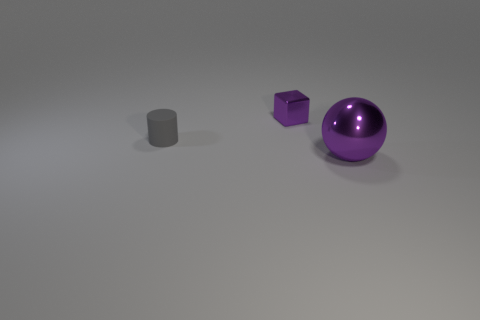Do the small matte thing and the large purple thing have the same shape?
Your answer should be very brief. No. The matte cylinder has what color?
Offer a very short reply. Gray. What number of things are big purple metallic spheres or purple rubber cubes?
Your answer should be very brief. 1. Is there anything else that has the same material as the gray cylinder?
Keep it short and to the point. No. Is the number of small gray objects that are right of the big purple object less than the number of tiny objects?
Give a very brief answer. Yes. Are there more big purple balls that are to the left of the tiny gray matte thing than shiny spheres behind the purple metal ball?
Ensure brevity in your answer.  No. Is there any other thing that is the same color as the big metallic ball?
Keep it short and to the point. Yes. What is the purple thing that is in front of the gray rubber cylinder made of?
Offer a terse response. Metal. Do the metallic ball and the metallic block have the same size?
Your answer should be very brief. No. How many other things are there of the same size as the metallic ball?
Give a very brief answer. 0. 